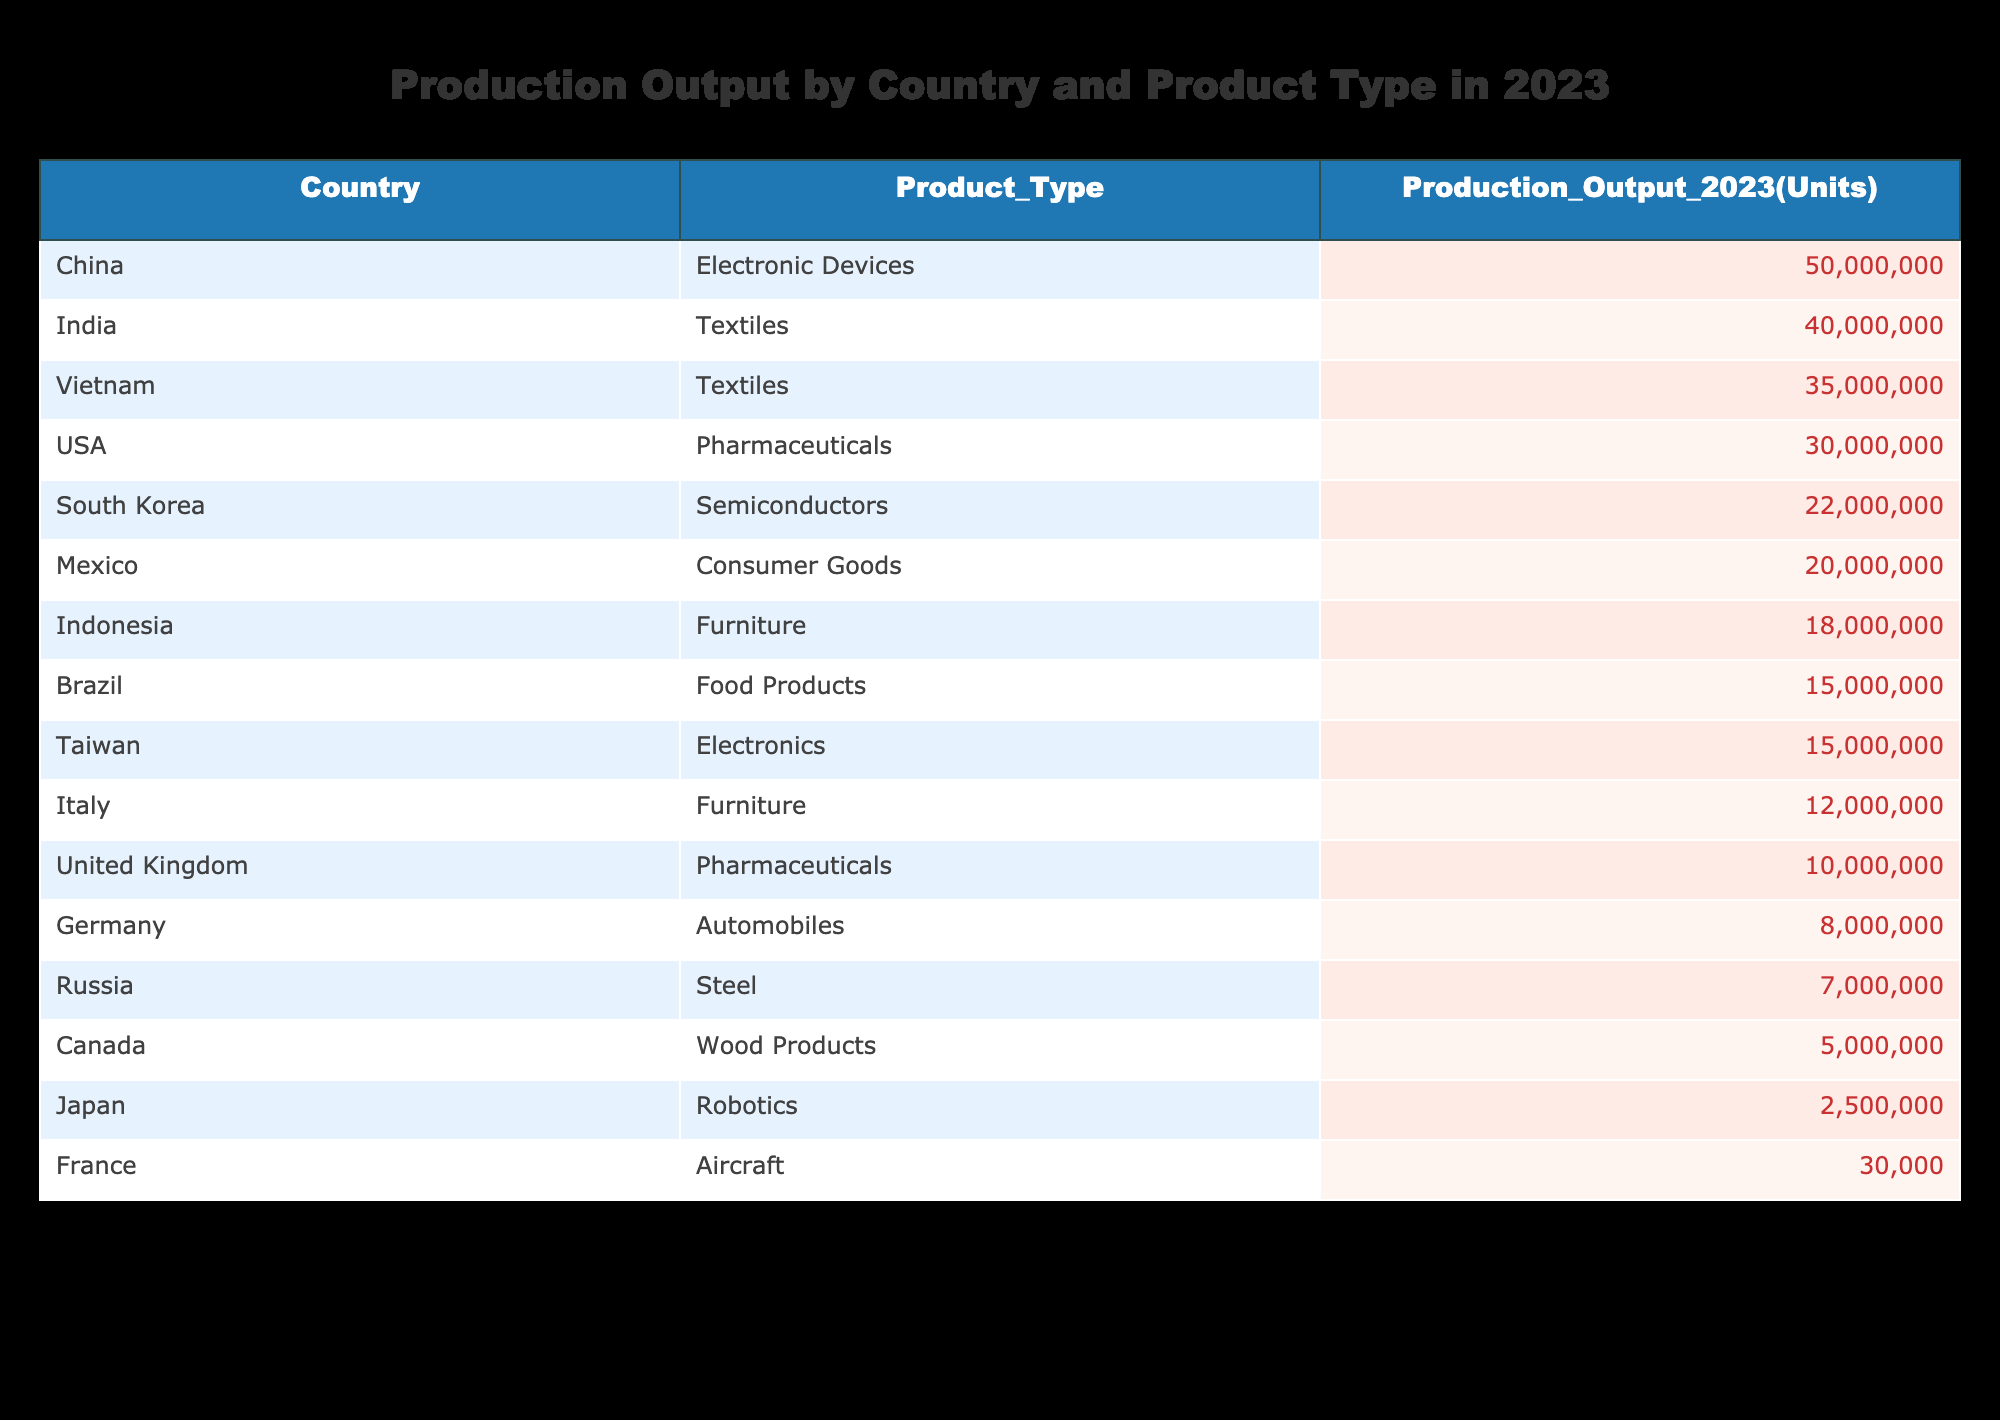What country produced the highest number of electronic devices in 2023? Looking at the table, China is listed under Electronic Devices with a production output of 50,000,000 units. No other country is listed under this product type, making China the country with the highest production in this category.
Answer: China Which country had the lowest production output in the table? Upon reviewing the production outputs listed, the table shows France with 30,000 units for Aircraft, which is significantly lower than all other entries. Therefore, France has the lowest production output in the table.
Answer: France How many units of pharmaceuticals were produced by the USA and the United Kingdom combined? The USA produced 30,000,000 units of Pharmaceuticals and the United Kingdom produced 10,000,000 units. Adding these together gives 30,000,000 + 10,000,000 = 40,000,000 units.
Answer: 40000000 Is it true that India produced more textiles than Vietnam in 2023? India produced 40,000,000 units of Textiles while Vietnam produced 35,000,000 units. Since 40,000,000 is greater than 35,000,000, the statement is true.
Answer: Yes What is the average production output across all countries listed for the furniture product type? Looking at the table, Italy produced 12,000,000 units and Indonesia produced 18,000,000 units of Furniture. The total for Furniture is 12,000,000 + 18,000,000 = 30,000,000 units. Since there are two entries, the average is 30,000,000 / 2 = 15,000,000.
Answer: 15000000 Which country has the highest production output for food products? The table specifies Brazil as the only country listed under Food Products with a production output of 15,000,000 units, making it the highest for this category since no other countries are mentioned.
Answer: Brazil How many total units of electronic devices and electronics were produced by all countries listed? China produced 50,000,000 units of Electronic Devices and Taiwan produced 15,000,000 units of Electronics. Therefore, the total production for both categories combined amounts to 50,000,000 + 15,000,000 = 65,000,000 units.
Answer: 65000000 Which country produced more semiconductors than Japan produced in robotics? South Korea produced 22,000,000 units of Semiconductors while Japan produced only 2,500,000 units in Robotics. Since 22,000,000 is greater than 2,500,000, South Korea is the country that produced more.
Answer: South Korea 